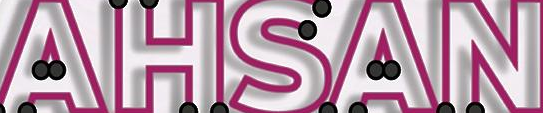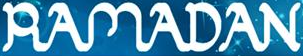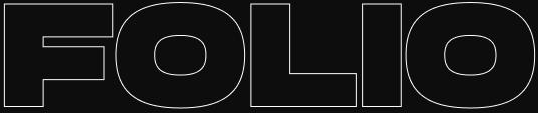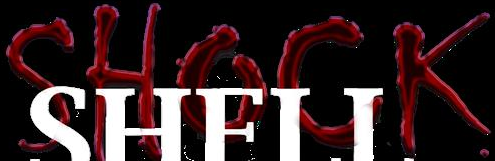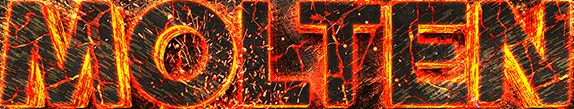Identify the words shown in these images in order, separated by a semicolon. AHSAN; RAMADAN; FOLIO; SHOCK; MOLTEN 